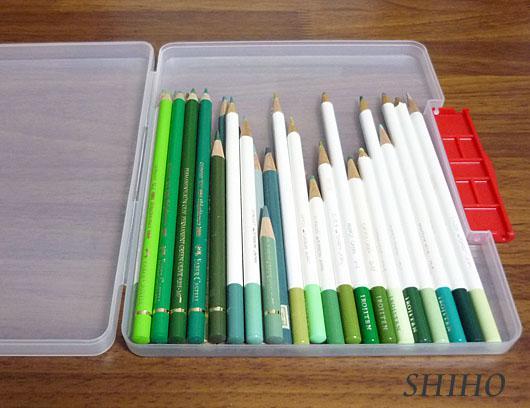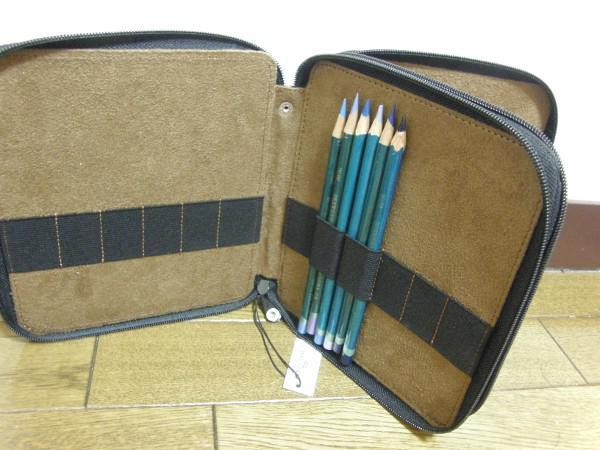The first image is the image on the left, the second image is the image on the right. Considering the images on both sides, is "In at least one picture all of the colored pencils are pointing up." valid? Answer yes or no. Yes. The first image is the image on the left, the second image is the image on the right. Assess this claim about the two images: "The pencils in the left image are supported with bands.". Correct or not? Answer yes or no. No. 